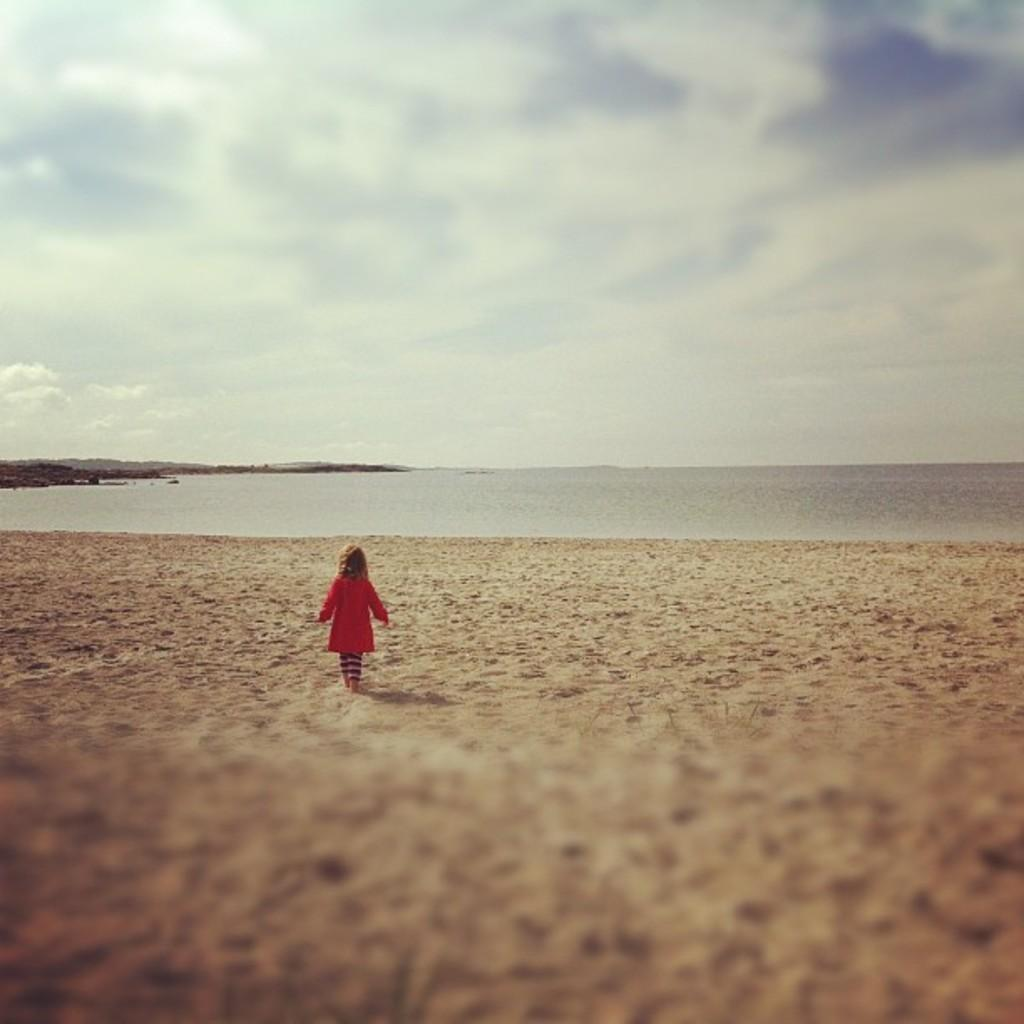What is the main subject of the image? The main subject of the image is a kid. What is the kid doing in the image? The kid is walking in the image. What type of terrain is visible at the bottom of the image? There is sand at the bottom of the image. What can be seen in the background of the image? There is water visible in the background of the image. What is visible at the top of the image? The sky is visible at the top of the image. What can be observed in the sky? Clouds are present in the sky. What type of metal is the cub using to build a sandcastle in the image? There is no cub or metal present in the image. Who is the owner of the water visible in the background of the image? The image does not provide information about the ownership of the water. 